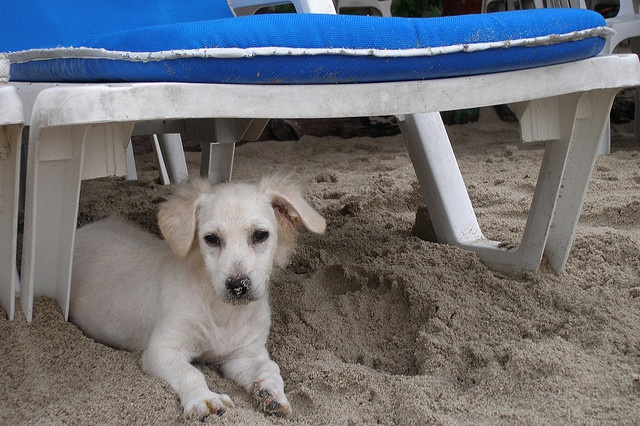Describe the objects in this image and their specific colors. I can see chair in blue, gray, darkgray, and lightgray tones and dog in blue, darkgray, and gray tones in this image. 